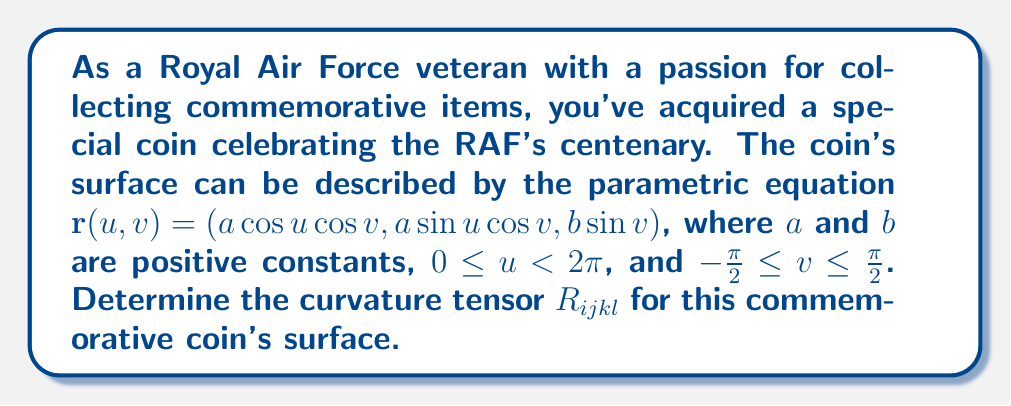Help me with this question. To find the curvature tensor, we'll follow these steps:

1) First, calculate the metric tensor $g_{ij}$:
   $$\mathbf{r}_u = (-a\sin u \cos v, a\cos u \cos v, 0)$$
   $$\mathbf{r}_v = (-a\cos u \sin v, -a\sin u \sin v, b\cos v)$$
   
   $$g_{11} = a^2\cos^2 v$$
   $$g_{12} = g_{21} = 0$$
   $$g_{22} = a^2\sin^2 v + b^2\cos^2 v$$

2) Calculate the Christoffel symbols:
   $$\Gamma_{11}^1 = 0, \Gamma_{11}^2 = \frac{\sin v \cos v}{a^2\sin^2 v + b^2\cos^2 v}$$
   $$\Gamma_{12}^1 = \Gamma_{21}^1 = \tan v, \Gamma_{12}^2 = \Gamma_{21}^2 = 0$$
   $$\Gamma_{22}^1 = -\frac{a^2\sin v \cos v}{a^2\cos^2 v}, \Gamma_{22}^2 = \frac{(b^2-a^2)\sin v \cos v}{a^2\sin^2 v + b^2\cos^2 v}$$

3) Calculate the Riemann curvature tensor:
   $$R_{ijkl} = \partial_k \Gamma_{ilj} - \partial_l \Gamma_{ikj} + \Gamma_{ikm}\Gamma_{lj}^m - \Gamma_{ilm}\Gamma_{kj}^m$$

4) The non-zero components of $R_{ijkl}$ are:
   $$R_{1212} = R_{2121} = -R_{1221} = -R_{2112} = \frac{a^2b^2\cos^2 v}{a^2\sin^2 v + b^2\cos^2 v}$$

5) The curvature tensor in mixed form:
   $$R_{ij}^{kl} = g^{km}g^{ln}R_{ijmn}$$

   $$R_{12}^{12} = R_{21}^{21} = -R_{12}^{21} = -R_{21}^{12} = \frac{b^2}{a^2(a^2\sin^2 v + b^2\cos^2 v)}$$
Answer: $R_{1212} = R_{2121} = -R_{1221} = -R_{2112} = \frac{a^2b^2\cos^2 v}{a^2\sin^2 v + b^2\cos^2 v}$ 